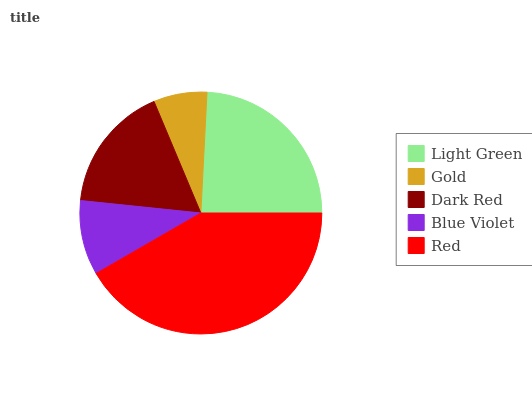Is Gold the minimum?
Answer yes or no. Yes. Is Red the maximum?
Answer yes or no. Yes. Is Dark Red the minimum?
Answer yes or no. No. Is Dark Red the maximum?
Answer yes or no. No. Is Dark Red greater than Gold?
Answer yes or no. Yes. Is Gold less than Dark Red?
Answer yes or no. Yes. Is Gold greater than Dark Red?
Answer yes or no. No. Is Dark Red less than Gold?
Answer yes or no. No. Is Dark Red the high median?
Answer yes or no. Yes. Is Dark Red the low median?
Answer yes or no. Yes. Is Light Green the high median?
Answer yes or no. No. Is Light Green the low median?
Answer yes or no. No. 